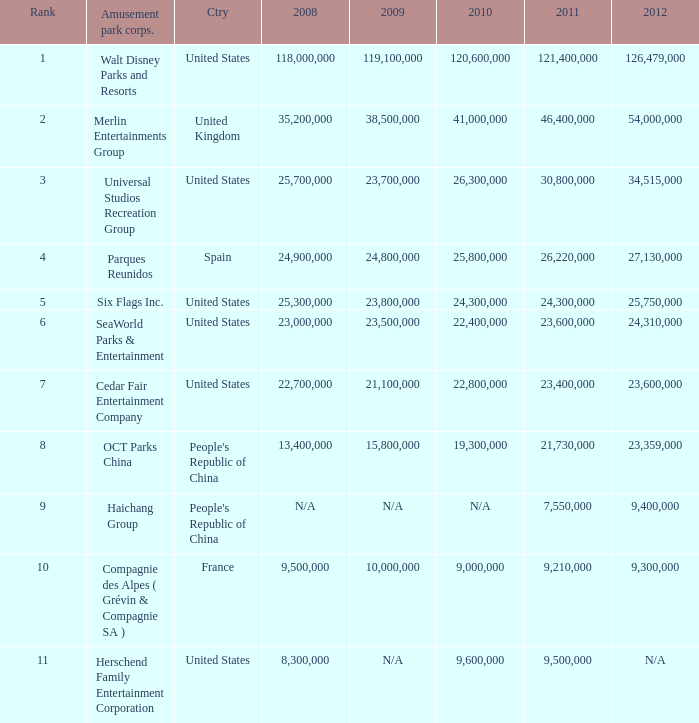What is the Rank listed for the attendance of 2010 of 9,000,000 and 2011 larger than 9,210,000? None. 